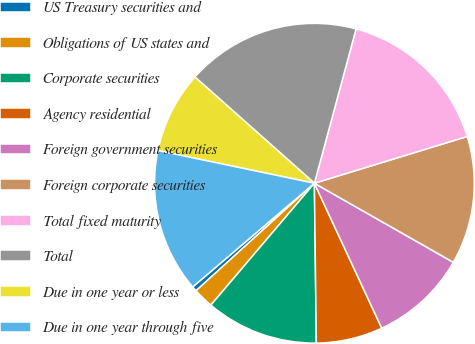Convert chart to OTSL. <chart><loc_0><loc_0><loc_500><loc_500><pie_chart><fcel>US Treasury securities and<fcel>Obligations of US states and<fcel>Corporate securities<fcel>Agency residential<fcel>Foreign government securities<fcel>Foreign corporate securities<fcel>Total fixed maturity<fcel>Total<fcel>Due in one year or less<fcel>Due in one year through five<nl><fcel>0.5%<fcel>2.06%<fcel>11.4%<fcel>6.73%<fcel>9.84%<fcel>12.96%<fcel>16.07%<fcel>17.63%<fcel>8.29%<fcel>14.51%<nl></chart> 